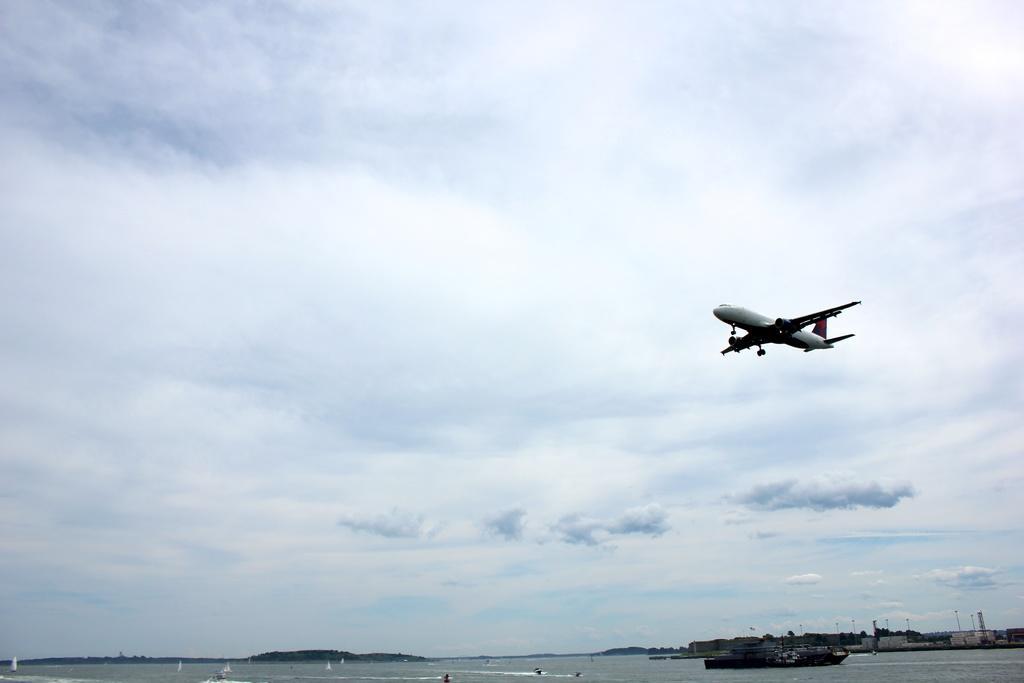Can you describe this image briefly? In this image we can see a boat floating on the water, trees, towers, an airplane flying in the air and the cloudy sky in the background. 